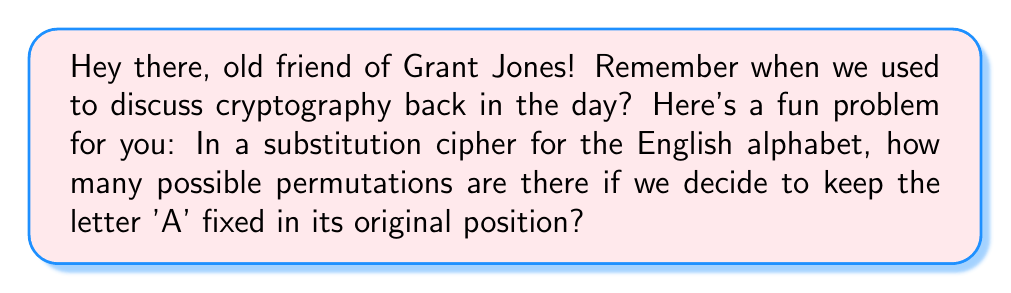Can you solve this math problem? Let's approach this step-by-step:

1) First, recall that a substitution cipher replaces each letter in the plaintext with another letter in the alphabet.

2) The English alphabet has 26 letters.

3) We're keeping 'A' fixed, so we only need to permute the remaining 25 letters.

4) This is a straightforward permutation problem. The number of permutations of n distinct objects is given by n!

5) In this case, we're permuting 25 letters, so the number of permutations is:

   $$25! = 25 \times 24 \times 23 \times ... \times 3 \times 2 \times 1$$

6) This can be calculated as:

   $$25! = 15,511,210,043,330,985,984,000,000$$

Therefore, there are approximately $1.55 \times 10^{25}$ possible permutations in this substitution cipher with 'A' fixed.
Answer: $25!$ or $15,511,210,043,330,985,984,000,000$ 